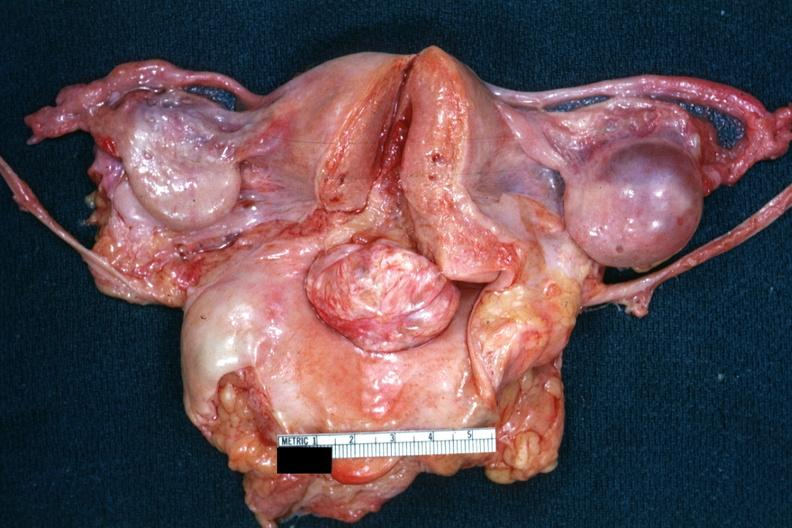s female reproductive present?
Answer the question using a single word or phrase. Yes 